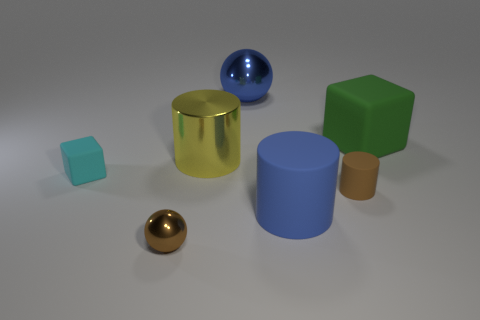There is a cyan object that is made of the same material as the big green block; what is its shape?
Ensure brevity in your answer.  Cube. What size is the blue object that is made of the same material as the yellow cylinder?
Provide a succinct answer. Large. There is a small thing that is behind the tiny metallic object and on the right side of the small cyan cube; what is its shape?
Make the answer very short. Cylinder. There is a cylinder that is behind the tiny brown object to the right of the tiny brown metal ball; what size is it?
Give a very brief answer. Large. What number of other objects are there of the same color as the tiny sphere?
Your answer should be very brief. 1. What is the small block made of?
Your response must be concise. Rubber. Is there a tiny brown rubber cube?
Your answer should be compact. No. Are there the same number of blue rubber cylinders in front of the small sphere and big blue balls?
Your answer should be very brief. No. How many small objects are either spheres or cylinders?
Provide a short and direct response. 2. There is a matte object that is the same color as the small shiny thing; what shape is it?
Your answer should be very brief. Cylinder. 